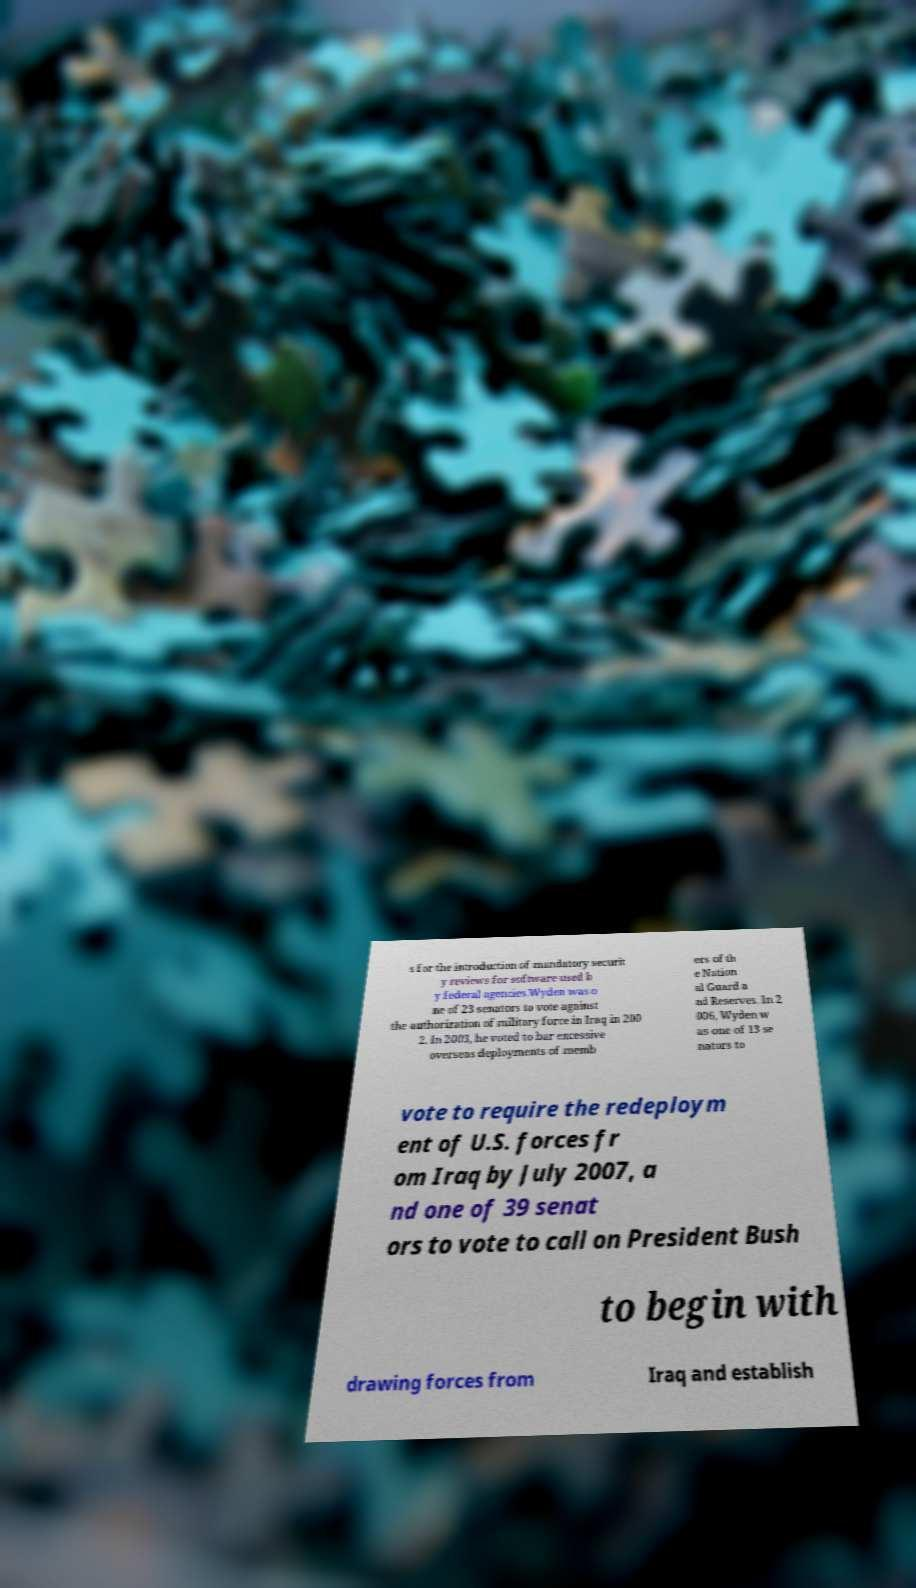Please read and relay the text visible in this image. What does it say? s for the introduction of mandatory securit y reviews for software used b y federal agencies.Wyden was o ne of 23 senators to vote against the authorization of military force in Iraq in 200 2. In 2003, he voted to bar excessive overseas deployments of memb ers of th e Nation al Guard a nd Reserves. In 2 006, Wyden w as one of 13 se nators to vote to require the redeploym ent of U.S. forces fr om Iraq by July 2007, a nd one of 39 senat ors to vote to call on President Bush to begin with drawing forces from Iraq and establish 